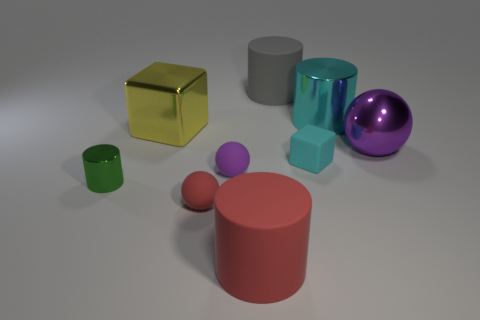How many tiny objects are either green rubber balls or cyan things?
Your answer should be compact. 1. Are there the same number of red rubber balls on the left side of the gray rubber object and yellow blocks?
Your answer should be very brief. Yes. Are there any large gray things behind the yellow block behind the tiny red matte thing?
Offer a very short reply. Yes. How many other things are the same color as the small block?
Ensure brevity in your answer.  1. What is the color of the large sphere?
Your answer should be very brief. Purple. What size is the thing that is both to the left of the big gray rubber cylinder and behind the small matte block?
Provide a short and direct response. Large. What number of objects are metallic things on the left side of the yellow object or big cyan matte spheres?
Make the answer very short. 1. The big cyan object that is made of the same material as the big purple thing is what shape?
Ensure brevity in your answer.  Cylinder. The small cyan matte object has what shape?
Make the answer very short. Cube. What color is the ball that is both in front of the purple shiny object and behind the tiny red sphere?
Keep it short and to the point. Purple. 